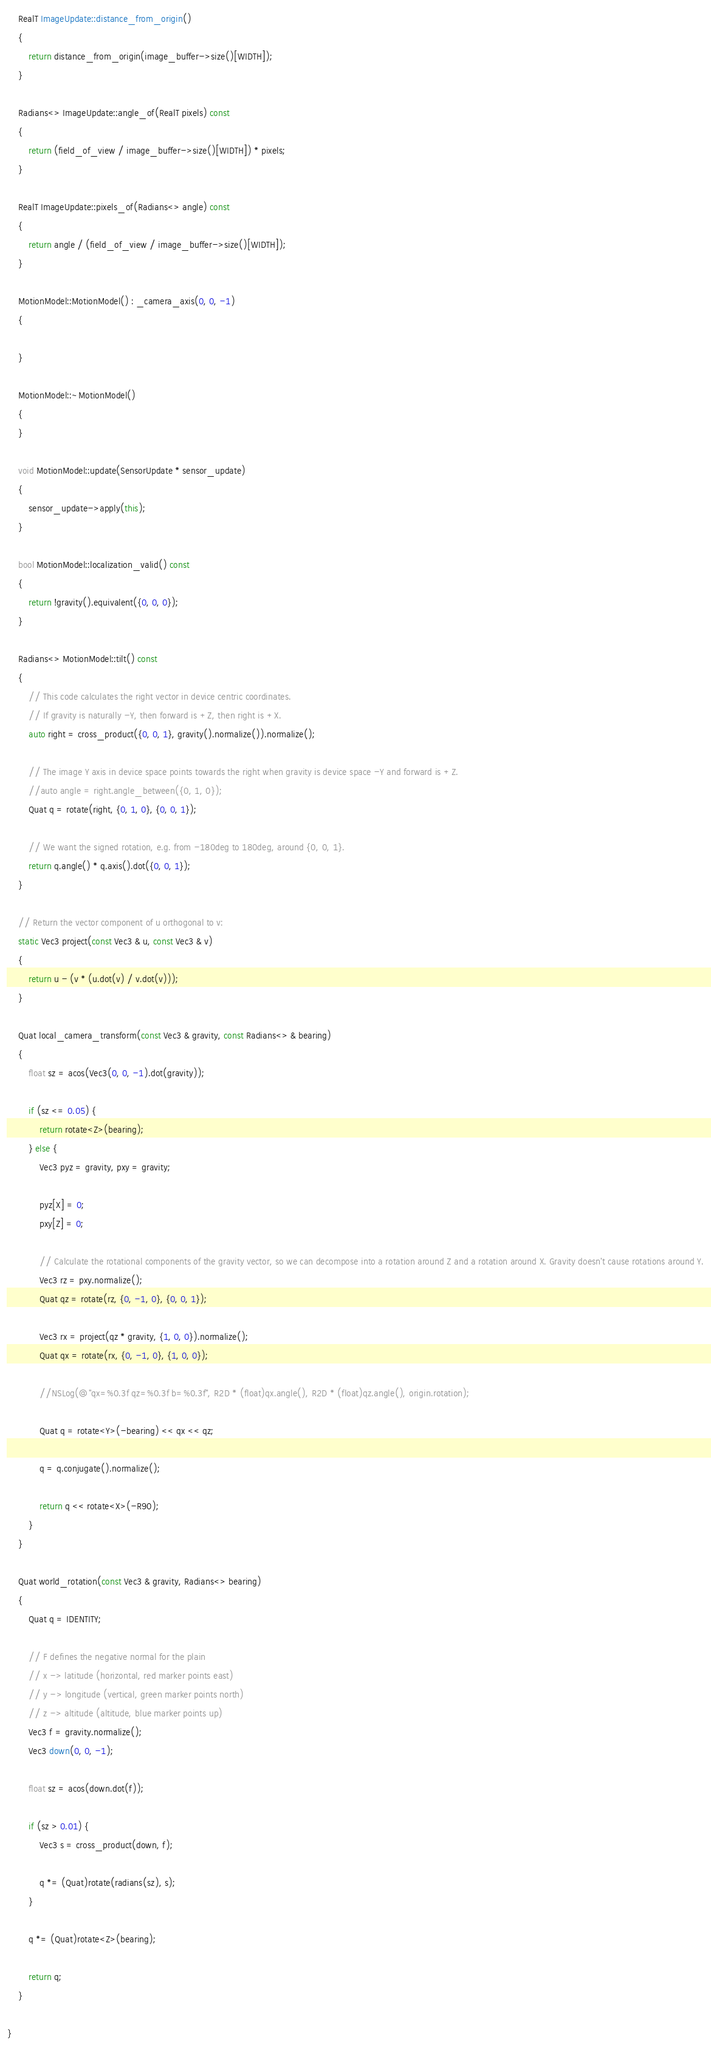<code> <loc_0><loc_0><loc_500><loc_500><_C++_>	RealT ImageUpdate::distance_from_origin()
	{
		return distance_from_origin(image_buffer->size()[WIDTH]);
	}

	Radians<> ImageUpdate::angle_of(RealT pixels) const
	{
		return (field_of_view / image_buffer->size()[WIDTH]) * pixels;
	}
	
	RealT ImageUpdate::pixels_of(Radians<> angle) const
	{
		return angle / (field_of_view / image_buffer->size()[WIDTH]);
	}

	MotionModel::MotionModel() : _camera_axis(0, 0, -1)
	{
		
	}

	MotionModel::~MotionModel()
	{
	}

	void MotionModel::update(SensorUpdate * sensor_update)
	{
		sensor_update->apply(this);
	}

	bool MotionModel::localization_valid() const
	{
		return !gravity().equivalent({0, 0, 0});
	}

	Radians<> MotionModel::tilt() const
	{
		// This code calculates the right vector in device centric coordinates.
		// If gravity is naturally -Y, then forward is +Z, then right is +X.
		auto right = cross_product({0, 0, 1}, gravity().normalize()).normalize();

		// The image Y axis in device space points towards the right when gravity is device space -Y and forward is +Z.
		//auto angle = right.angle_between({0, 1, 0});
		Quat q = rotate(right, {0, 1, 0}, {0, 0, 1});
		
		// We want the signed rotation, e.g. from -180deg to 180deg, around {0, 0, 1}.
		return q.angle() * q.axis().dot({0, 0, 1});
	}
	
	// Return the vector component of u orthogonal to v:
	static Vec3 project(const Vec3 & u, const Vec3 & v)
	{
		return u - (v * (u.dot(v) / v.dot(v)));
	}
	
	Quat local_camera_transform(const Vec3 & gravity, const Radians<> & bearing)
	{
		float sz = acos(Vec3(0, 0, -1).dot(gravity));
		
		if (sz <= 0.05) {
			return rotate<Z>(bearing);
		} else {
			Vec3 pyz = gravity, pxy = gravity;

			pyz[X] = 0;
			pxy[Z] = 0;

			// Calculate the rotational components of the gravity vector, so we can decompose into a rotation around Z and a rotation around X. Gravity doesn't cause rotations around Y.
			Vec3 rz = pxy.normalize();
			Quat qz = rotate(rz, {0, -1, 0}, {0, 0, 1});
		
			Vec3 rx = project(qz * gravity, {1, 0, 0}).normalize();
			Quat qx = rotate(rx, {0, -1, 0}, {1, 0, 0});

			//NSLog(@"qx=%0.3f qz=%0.3f b=%0.3f", R2D * (float)qx.angle(), R2D * (float)qz.angle(), origin.rotation);

			Quat q = rotate<Y>(-bearing) << qx << qz;

			q = q.conjugate().normalize();

			return q << rotate<X>(-R90);
		}
	}
	
	Quat world_rotation(const Vec3 & gravity, Radians<> bearing)
	{
		Quat q = IDENTITY;
		
		// F defines the negative normal for the plain
		// x -> latitude (horizontal, red marker points east)
		// y -> longitude (vertical, green marker points north)
		// z -> altitude (altitude, blue marker points up)
		Vec3 f = gravity.normalize();
		Vec3 down(0, 0, -1);

		float sz = acos(down.dot(f));
	
		if (sz > 0.01) {
			Vec3 s = cross_product(down, f);

			q *= (Quat)rotate(radians(sz), s);
		}

		q *= (Quat)rotate<Z>(bearing);

		return q;
	}
	
}
</code> 